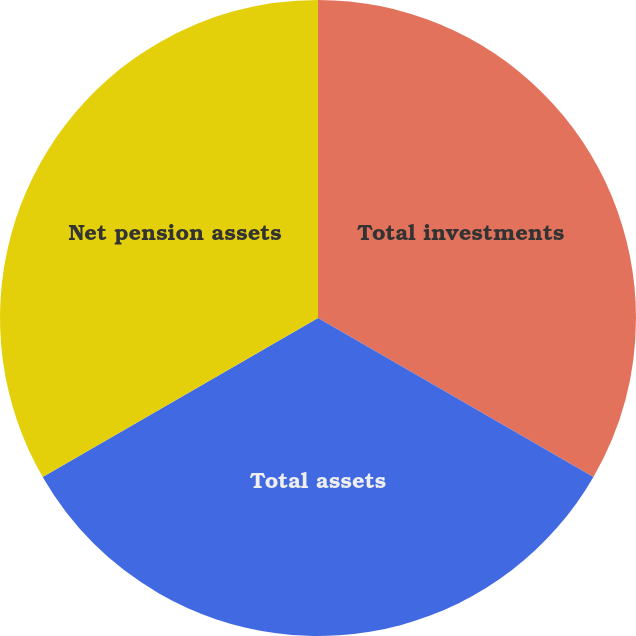<chart> <loc_0><loc_0><loc_500><loc_500><pie_chart><fcel>Total investments<fcel>Total assets<fcel>Net pension assets<nl><fcel>33.33%<fcel>33.33%<fcel>33.34%<nl></chart> 